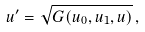<formula> <loc_0><loc_0><loc_500><loc_500>u ^ { \prime } = \sqrt { G ( u _ { 0 } , u _ { 1 } , u ) } \, ,</formula> 